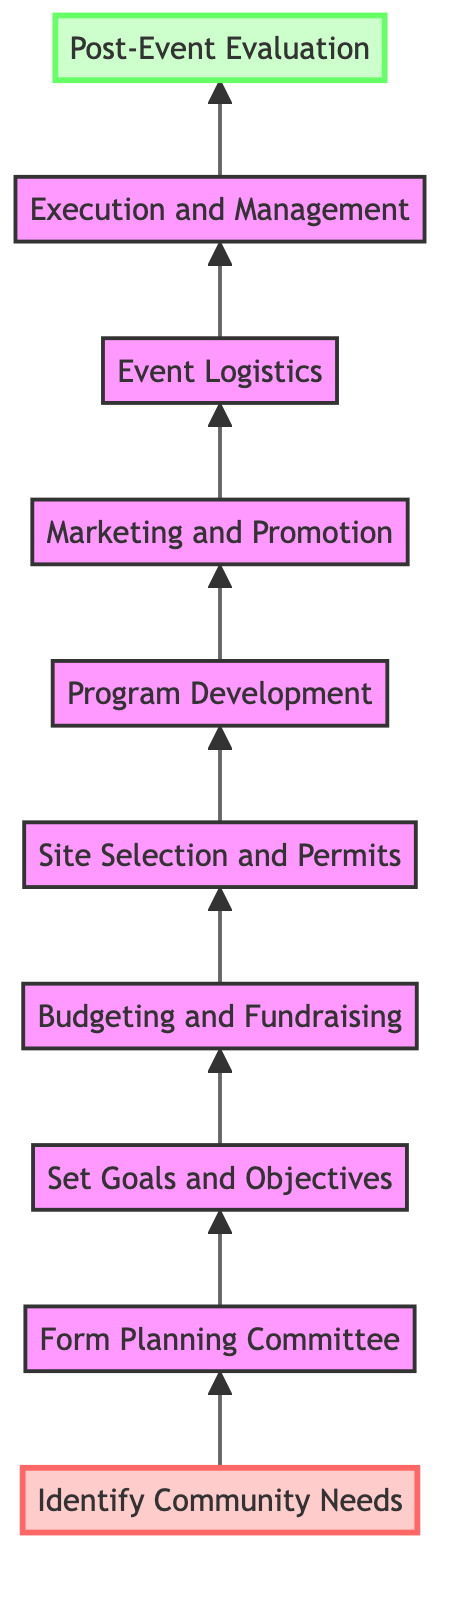What is the first step in the community event planning process? The first step is "Identify Community Needs," which is visually positioned at the bottom of the diagram.
Answer: Identify Community Needs How many steps are there in total? Counting from the first step at the bottom to the last step at the top, there are ten distinct steps represented in the diagram.
Answer: Ten What step directly follows "Site Selection and Permits"? The step that directly follows "Site Selection and Permits" is "Program Development," as indicated by the connecting arrow in the diagram.
Answer: Program Development Which step is at level 10? At level 10, the step is "Post-Event Evaluation," which is the final step in the diagram denoting the end of the planning process.
Answer: Post-Event Evaluation What is the purpose of the "Budgeting and Fundraising" step? This step aims to estimate costs and secure funding through various means, as detailed in its description in the diagram.
Answer: Estimate costs What is the relationship between "Execution and Management" and "Event Logistics"? "Execution and Management" is dependent on "Event Logistics" since it ensures that all operational details have been arranged before executing the actual event.
Answer: Dependent What is the main objective of "Set Goals and Objectives"? The main objective is to define the purpose, scope, and objectives of the event, which aligns with community needs.
Answer: Define purpose Which node is at the highest level? The highest level, which is level 10 in the diagram, has the node "Post-Event Evaluation," indicating it as the concluding step of the process.
Answer: Post-Event Evaluation What step involves creating a promotional plan? The step that involves creating a promotional plan is "Marketing and Promotion," as stated in the diagram's flow.
Answer: Marketing and Promotion Which step would you encounter directly after "Form Planning Committee"? The step directly after "Form Planning Committee" is "Set Goals and Objectives," which is the next action in the sequence.
Answer: Set Goals and Objectives 